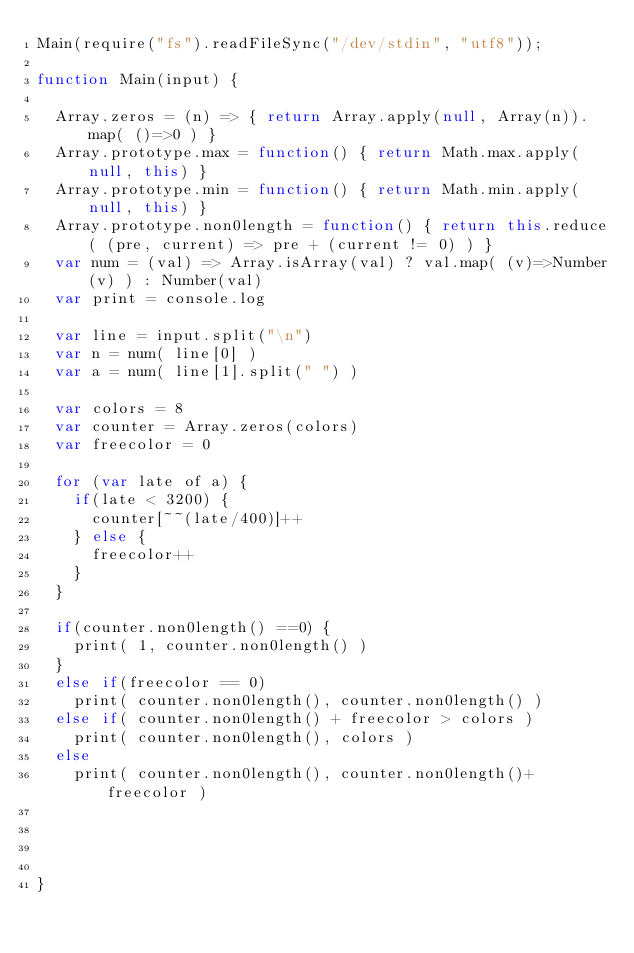<code> <loc_0><loc_0><loc_500><loc_500><_JavaScript_>Main(require("fs").readFileSync("/dev/stdin", "utf8"));

function Main(input) {

	Array.zeros = (n) => { return Array.apply(null, Array(n)).map( ()=>0 ) }
	Array.prototype.max = function() { return Math.max.apply(null, this) }
	Array.prototype.min = function() { return Math.min.apply(null, this) }
	Array.prototype.non0length = function() { return this.reduce( (pre, current) => pre + (current != 0) ) }
	var num = (val) => Array.isArray(val) ? val.map( (v)=>Number(v) ) : Number(val)
	var print = console.log

	var line = input.split("\n")
	var n = num( line[0] )
	var a = num( line[1].split(" ") )

	var colors = 8
	var counter = Array.zeros(colors)
	var freecolor = 0

	for (var late of a) {
		if(late < 3200) {
			counter[~~(late/400)]++
		} else {
			freecolor++
		}
	}

	if(counter.non0length() ==0) {
		print( 1, counter.non0length() )
	}
	else if(freecolor == 0)
		print( counter.non0length(), counter.non0length() )
	else if( counter.non0length() + freecolor > colors )
		print( counter.non0length(), colors )
	else
		print( counter.non0length(), counter.non0length()+freecolor )




}</code> 